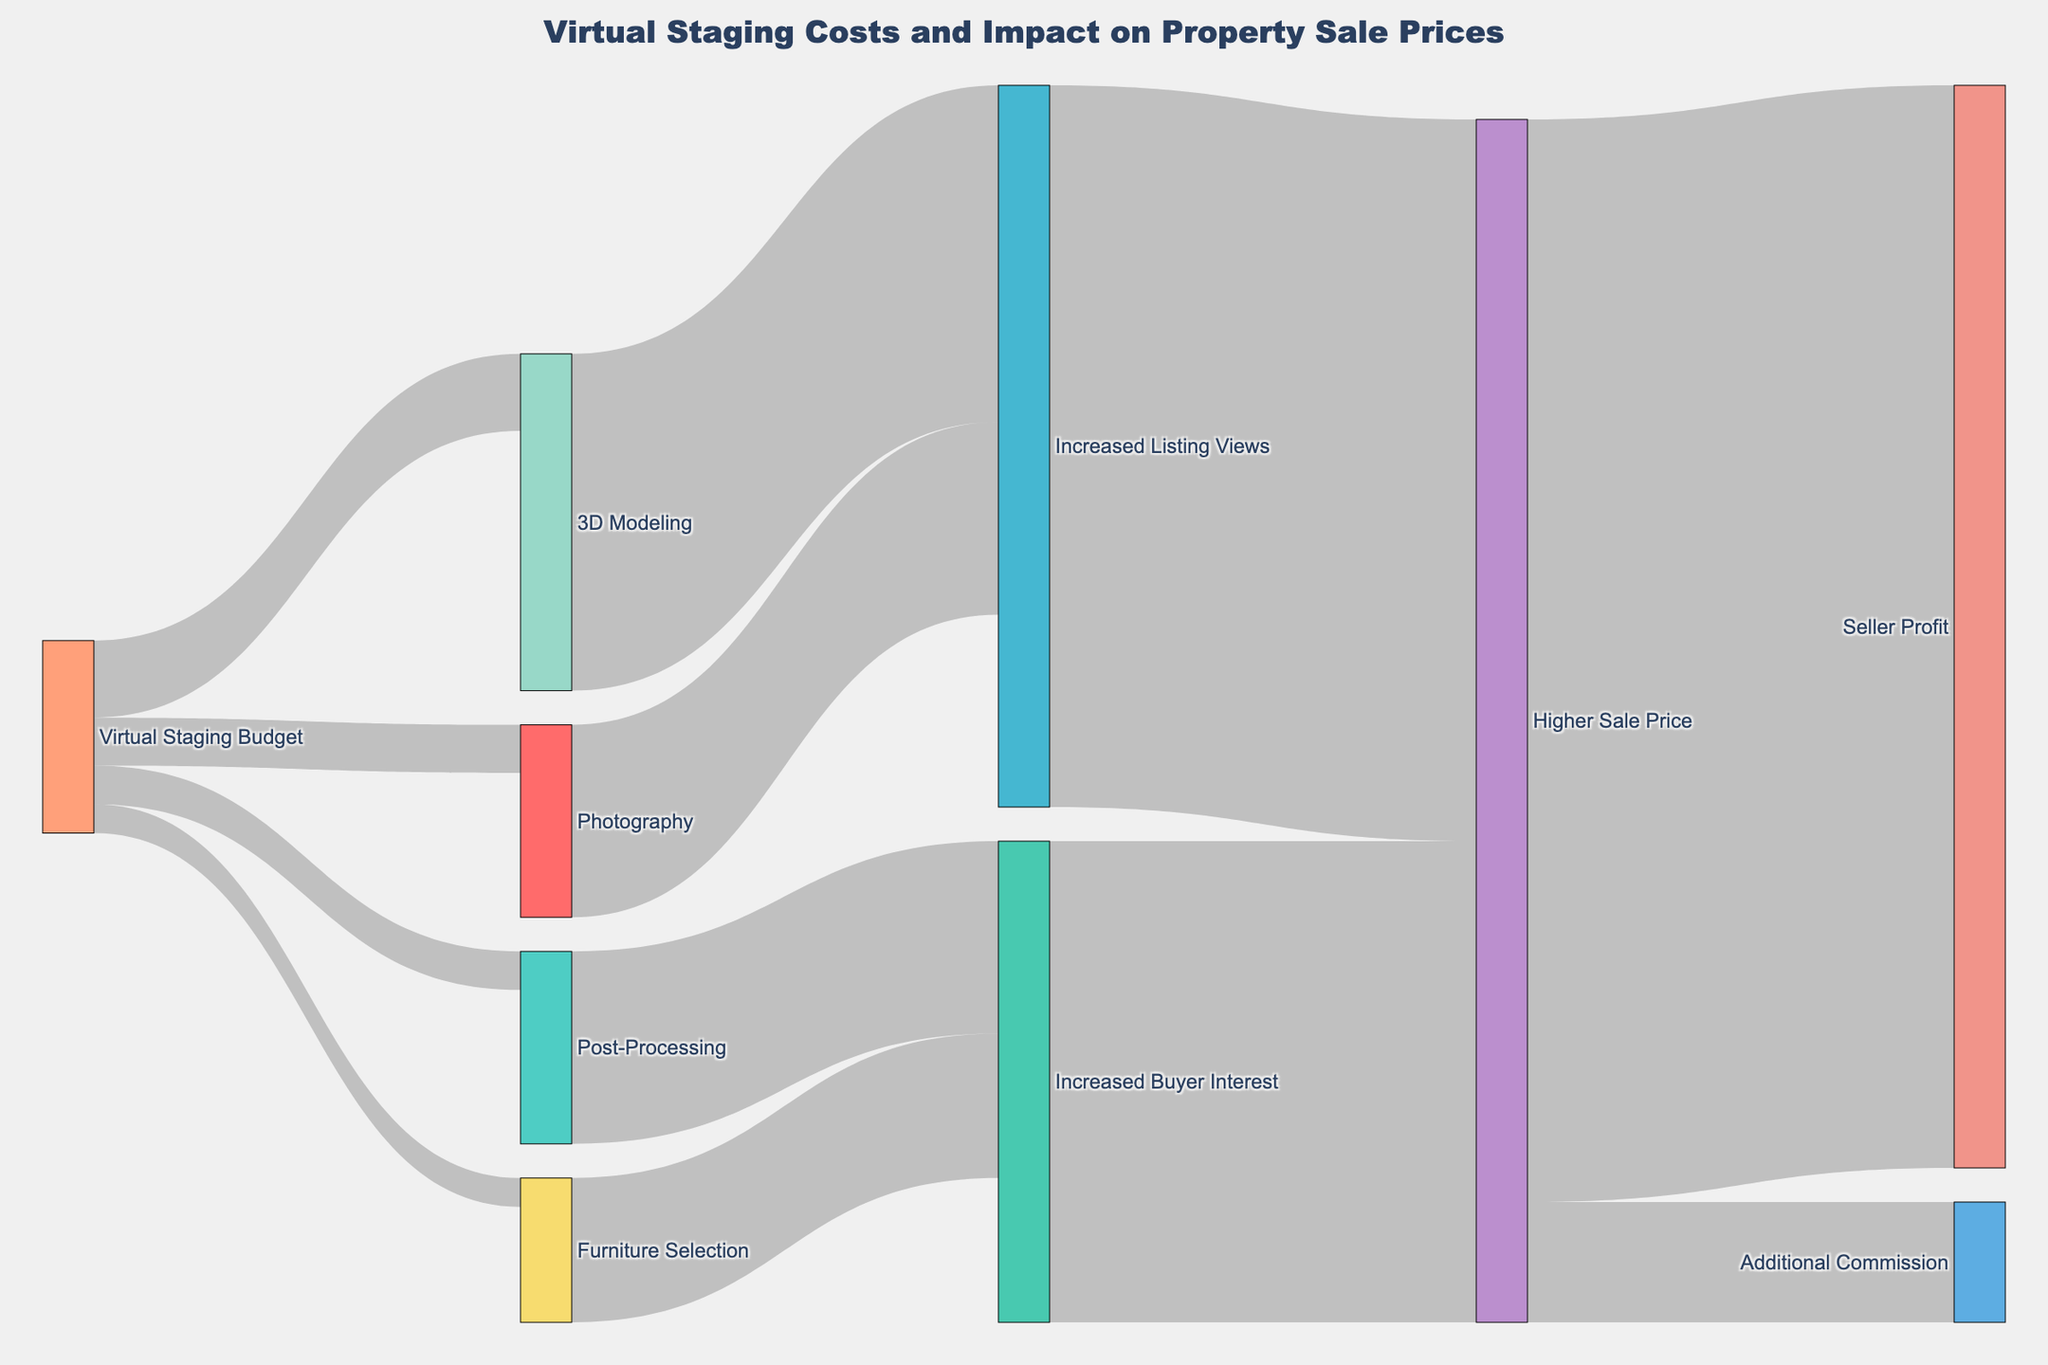How much is allocated to Photography from the Virtual Staging Budget? Look at the link "Virtual Staging Budget → Photography" in the diagram. The value indicated is 500.
Answer: 500 Which virtual staging component contributes the most to Increased Listing Views? Compare the values flowing from "Photography," "3D Modeling," and "Post-Processing" into "Increased Listing Views." The largest value is 3500 from "3D Modeling."
Answer: 3D Modeling What is the total cost of Post-Processing and Photography combined? Look at the values for "Virtual Staging Budget → Post-Processing" and "Virtual Staging Budget → Photography." Add these values: 400 + 500 = 900.
Answer: 900 Which has a greater impact on Higher Sale Price: Increased Listing Views or Increased Buyer Interest? Compare the values flowing into "Higher Sale Price." "Increased Listing Views" contributes 7500, and "Increased Buyer Interest" contributes 5000. 7500 is greater than 5000.
Answer: Increased Listing Views What is the combined impact of 3D Modeling and Furniture Selection on Increased Buyer Interest? Identify the value flowing from "Furniture Selection" and "Post-Processing" into "Increased Buyer Interest." Add "Furniture Selection" (1500) + "Post-Processing" (2000) = 3500.
Answer: 3500 How much additional commission is generated from the higher sale price? Look at the link "Higher Sale Price → Additional Commission." The value indicated is 1250.
Answer: 1250 What is the total virtual staging budget? Add all values flowing from "Virtual Staging Budget" to other nodes: Photography (500) + 3D Modeling (800) + Furniture Selection (300) + Post-Processing (400) = 2000.
Answer: 2000 What is the total amount flowing into Higher Sale Price from all sources? Add values flowing into "Higher Sale Price" from "Increased Listing Views" and "Increased Buyer Interest." 7500 + 5000 = 12500.
Answer: 12500 What fraction of the Increased Listing Views is attributed to Photography? Identify the values for "Photography" (2000) and total "Increased Listing Views" (2000 + 3500). The fraction is 2000 / (2000 + 3500) = 2000 / 5500 ≈ 0.36.
Answer: 0.36 What is the seller's profit from the higher sale price? Look at the link "Higher Sale Price → Seller Profit." The value indicated is 11250.
Answer: 11250 